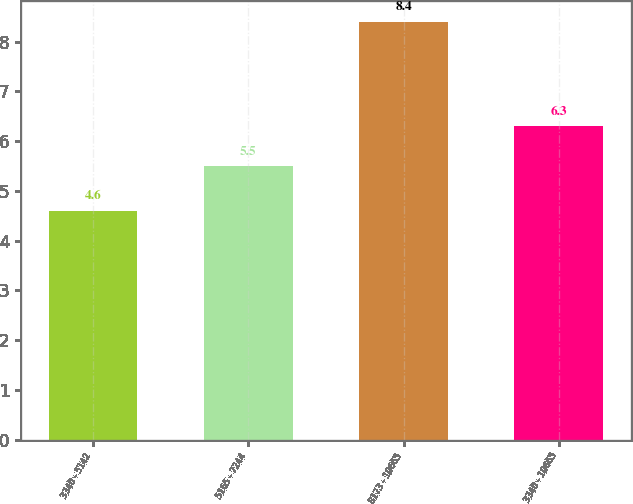<chart> <loc_0><loc_0><loc_500><loc_500><bar_chart><fcel>3340 - 5142<fcel>5165 - 7244<fcel>8173 - 10665<fcel>3340 - 10665<nl><fcel>4.6<fcel>5.5<fcel>8.4<fcel>6.3<nl></chart> 